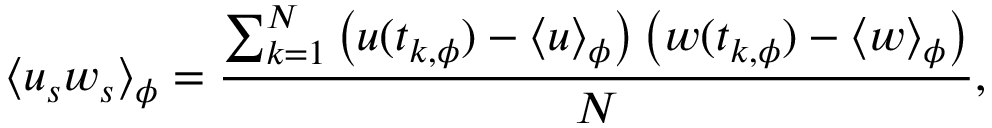Convert formula to latex. <formula><loc_0><loc_0><loc_500><loc_500>\langle u _ { s } w _ { s } \rangle _ { \phi } = \frac { \sum _ { k = 1 } ^ { N } \left ( u ( t _ { k , \phi } ) - \langle u \rangle _ { \phi } \right ) \left ( w ( t _ { k , \phi } ) - \langle w \rangle _ { \phi } \right ) } { N } ,</formula> 